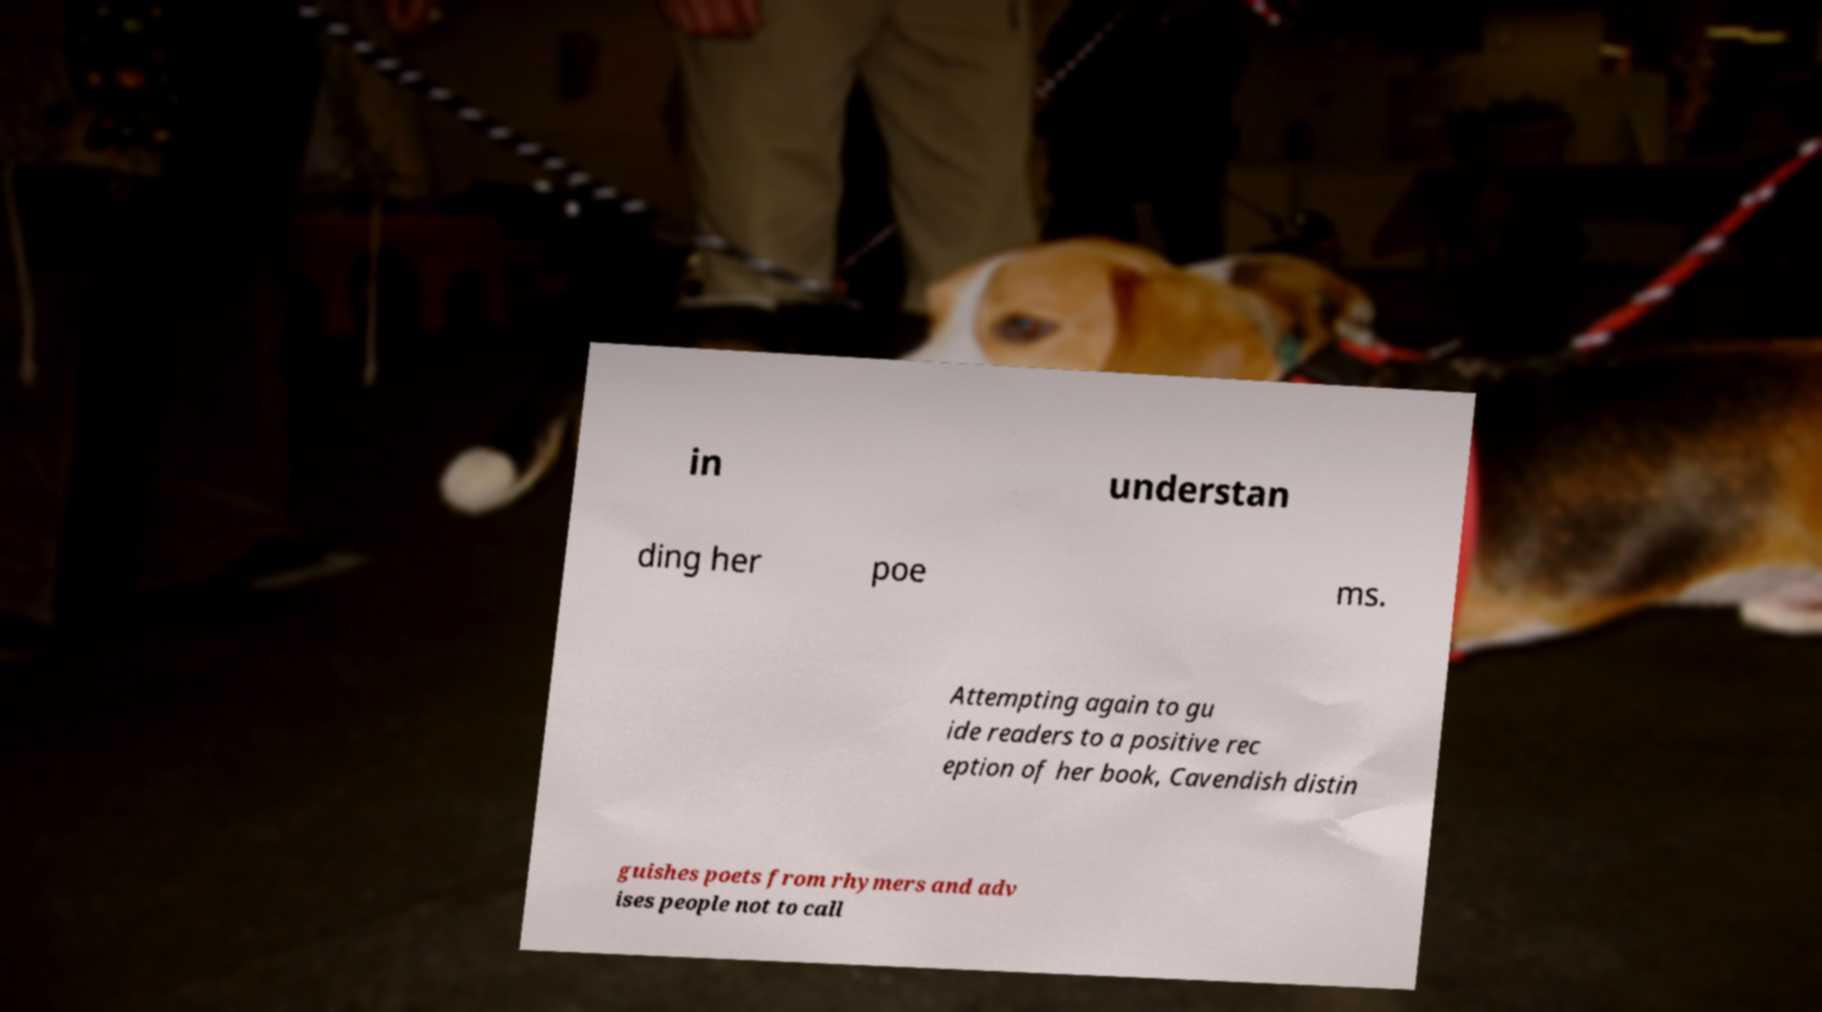Please read and relay the text visible in this image. What does it say? in understan ding her poe ms. Attempting again to gu ide readers to a positive rec eption of her book, Cavendish distin guishes poets from rhymers and adv ises people not to call 